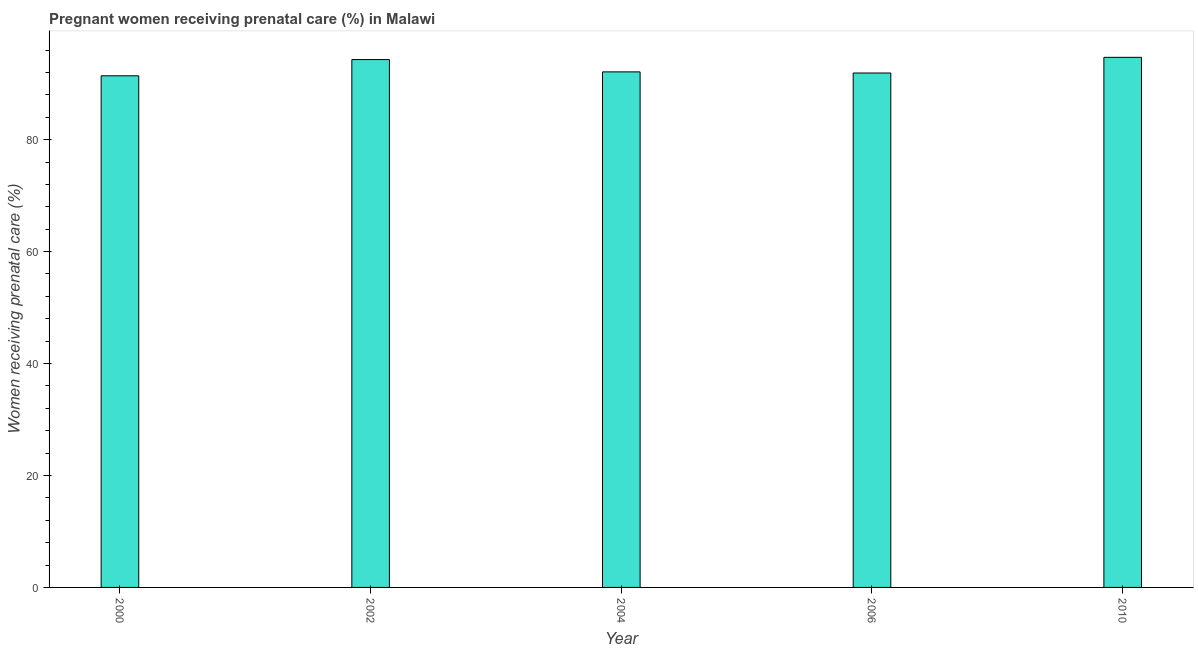What is the title of the graph?
Give a very brief answer. Pregnant women receiving prenatal care (%) in Malawi. What is the label or title of the X-axis?
Your response must be concise. Year. What is the label or title of the Y-axis?
Your response must be concise. Women receiving prenatal care (%). What is the percentage of pregnant women receiving prenatal care in 2002?
Ensure brevity in your answer.  94.3. Across all years, what is the maximum percentage of pregnant women receiving prenatal care?
Ensure brevity in your answer.  94.7. Across all years, what is the minimum percentage of pregnant women receiving prenatal care?
Your answer should be very brief. 91.4. In which year was the percentage of pregnant women receiving prenatal care maximum?
Provide a succinct answer. 2010. What is the sum of the percentage of pregnant women receiving prenatal care?
Your answer should be compact. 464.4. What is the difference between the percentage of pregnant women receiving prenatal care in 2004 and 2010?
Offer a terse response. -2.6. What is the average percentage of pregnant women receiving prenatal care per year?
Your response must be concise. 92.88. What is the median percentage of pregnant women receiving prenatal care?
Your response must be concise. 92.1. In how many years, is the percentage of pregnant women receiving prenatal care greater than 8 %?
Your response must be concise. 5. Do a majority of the years between 2002 and 2010 (inclusive) have percentage of pregnant women receiving prenatal care greater than 64 %?
Offer a terse response. Yes. What is the ratio of the percentage of pregnant women receiving prenatal care in 2000 to that in 2004?
Make the answer very short. 0.99. Is the percentage of pregnant women receiving prenatal care in 2000 less than that in 2010?
Your answer should be very brief. Yes. Is the difference between the percentage of pregnant women receiving prenatal care in 2002 and 2010 greater than the difference between any two years?
Your answer should be very brief. No. What is the difference between the highest and the second highest percentage of pregnant women receiving prenatal care?
Your answer should be compact. 0.4. Is the sum of the percentage of pregnant women receiving prenatal care in 2000 and 2002 greater than the maximum percentage of pregnant women receiving prenatal care across all years?
Provide a succinct answer. Yes. What is the difference between the highest and the lowest percentage of pregnant women receiving prenatal care?
Provide a succinct answer. 3.3. How many years are there in the graph?
Your response must be concise. 5. What is the Women receiving prenatal care (%) in 2000?
Offer a very short reply. 91.4. What is the Women receiving prenatal care (%) of 2002?
Your answer should be compact. 94.3. What is the Women receiving prenatal care (%) in 2004?
Make the answer very short. 92.1. What is the Women receiving prenatal care (%) in 2006?
Your answer should be very brief. 91.9. What is the Women receiving prenatal care (%) of 2010?
Provide a succinct answer. 94.7. What is the difference between the Women receiving prenatal care (%) in 2000 and 2002?
Make the answer very short. -2.9. What is the difference between the Women receiving prenatal care (%) in 2000 and 2004?
Your answer should be very brief. -0.7. What is the difference between the Women receiving prenatal care (%) in 2000 and 2006?
Your answer should be very brief. -0.5. What is the difference between the Women receiving prenatal care (%) in 2002 and 2010?
Ensure brevity in your answer.  -0.4. What is the ratio of the Women receiving prenatal care (%) in 2002 to that in 2004?
Offer a terse response. 1.02. What is the ratio of the Women receiving prenatal care (%) in 2002 to that in 2006?
Ensure brevity in your answer.  1.03. What is the ratio of the Women receiving prenatal care (%) in 2002 to that in 2010?
Your answer should be very brief. 1. What is the ratio of the Women receiving prenatal care (%) in 2004 to that in 2006?
Your answer should be compact. 1. 